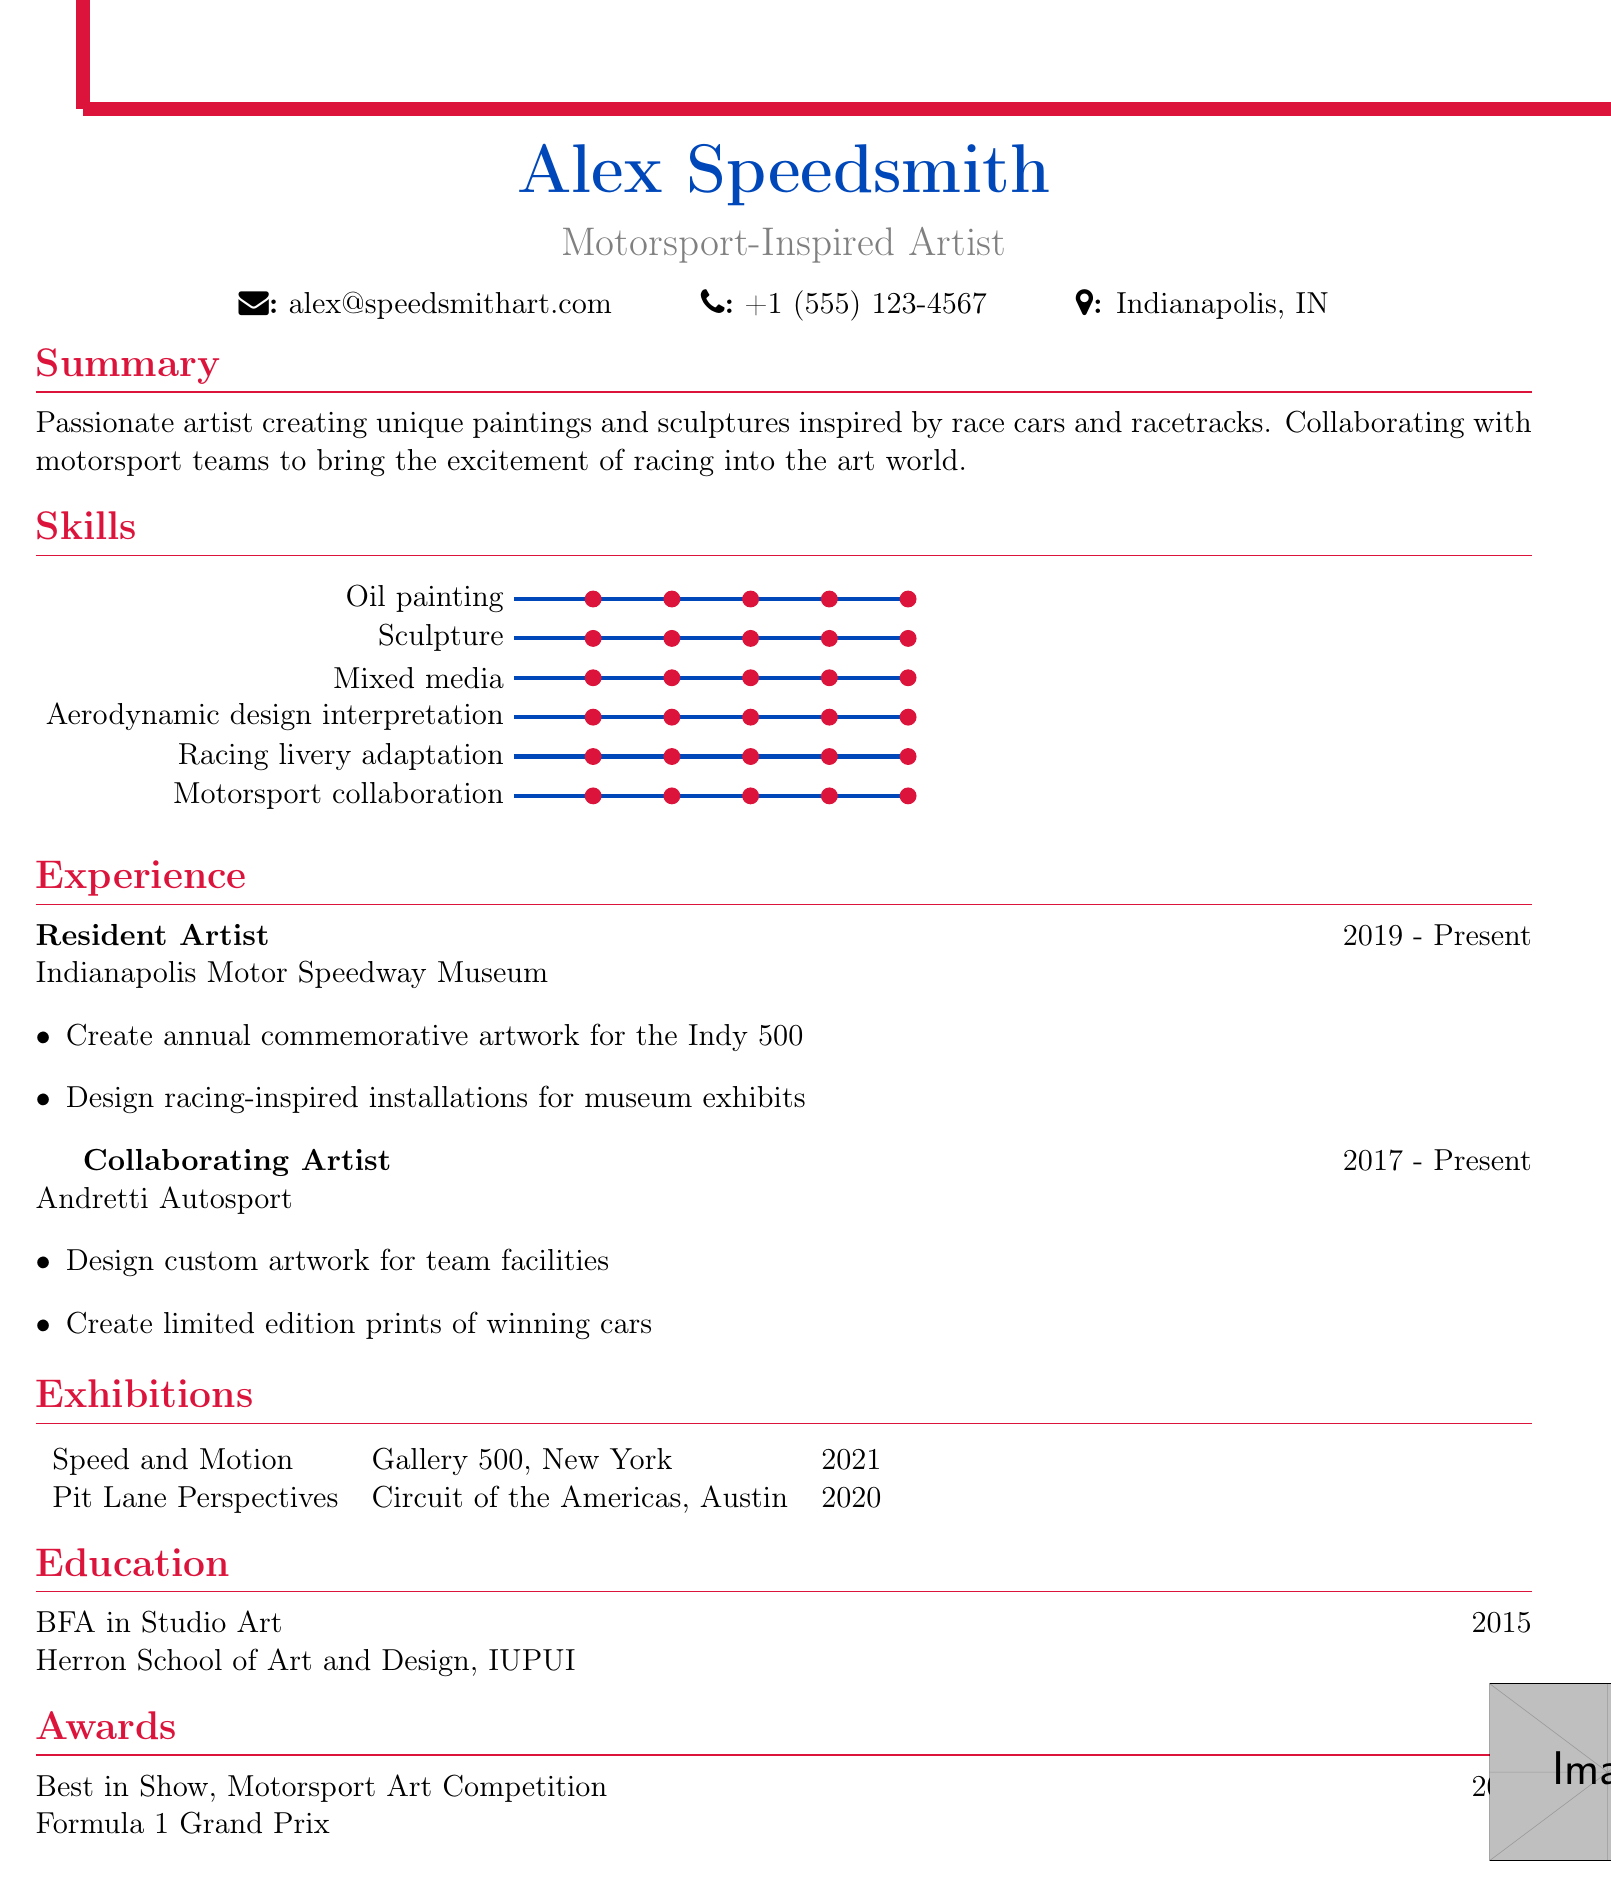what is the name of the artist? The artist's name is listed at the top of the document.
Answer: Alex Speedsmith what is the title of the artist? The title appears just below the artist's name and indicates their area of expertise.
Answer: Motorsport-Inspired Artist how many years has the artist worked at the Indianapolis Motor Speedway Museum? The duration of employment is provided in the experience section of the document.
Answer: 4 years which award did the artist win in 2022? The award information can be found in the awards section of the document.
Answer: Best in Show where did the artist receive their education? The education section directly states the institution attended by the artist.
Answer: Herron School of Art and Design, IUPUI what year was the exhibition "Pit Lane Perspectives" held? The year of the exhibition is listed in the exhibitions table of the document.
Answer: 2020 how many skills are listed in the document? By counting the skills mentioned in the skills section, the total can be determined.
Answer: 6 skills which racing team does the artist collaborate with? The specific racing team involved in collaboration is mentioned in the experience section.
Answer: Andretti Autosport what design element features a racing theme? The design elements include themes that relate to racing, as specified in the document.
Answer: Checkered flag border 